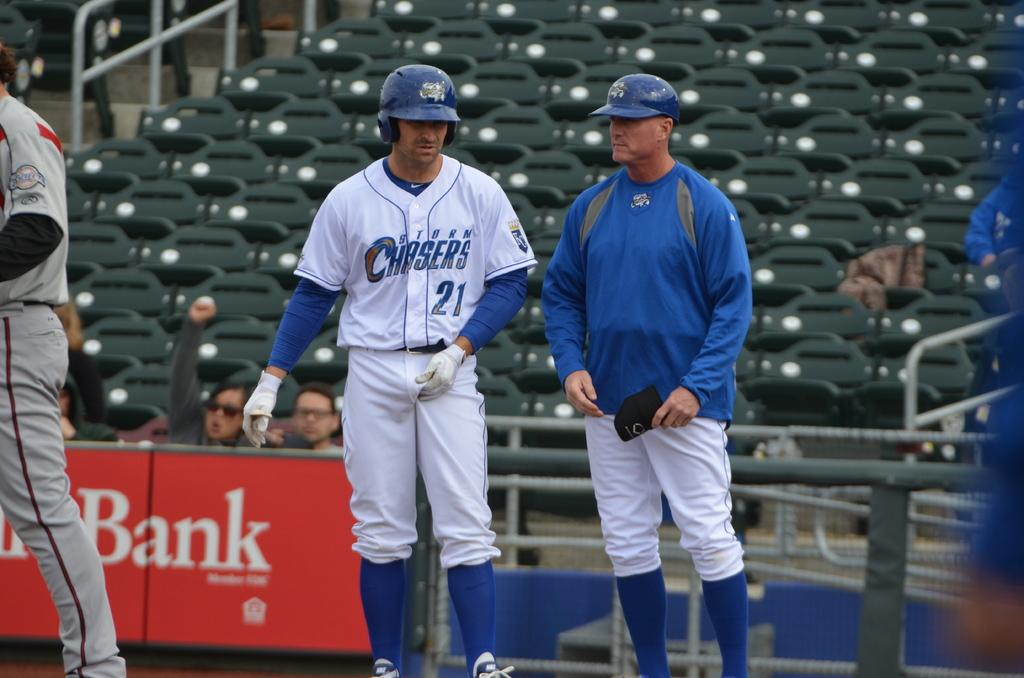<image>
Present a compact description of the photo's key features. Storm Chasers player number 21 wears a batting helmet and talks to a coach. 